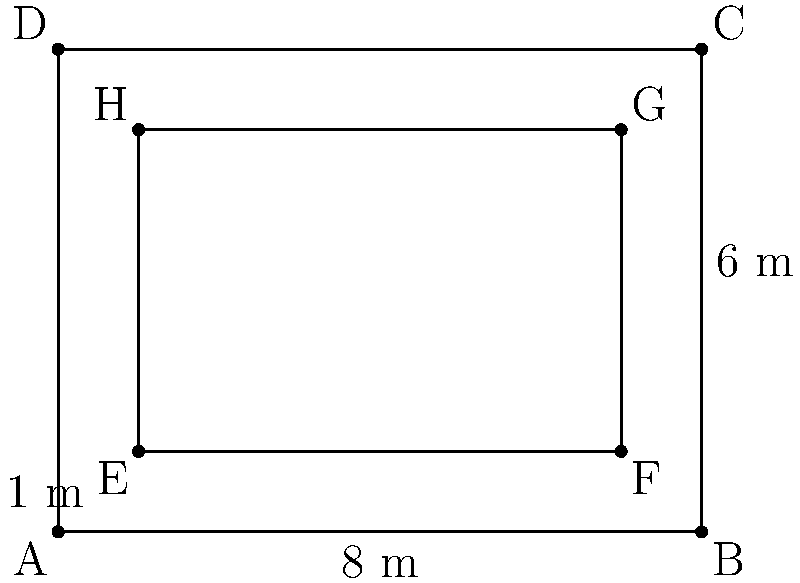Father, as we plan the landscaping for our new church courtyard, we need to calculate its perimeter. The courtyard is rectangular with dimensions 8 m by 6 m, but it has landscaped corners that are 1 m by 1 m squares. What is the perimeter of this irregularly shaped courtyard? Let's approach this step-by-step:

1) First, let's calculate the perimeter of the outer rectangle:
   $$P_{outer} = 2(8 + 6) = 28 \text{ m}$$

2) Now, we need to account for the landscaped corners. Each corner removes a 1 m by 1 m square from the perimeter.

3) For each corner, we remove 2 m from the outer perimeter (1 m from each side), but we add 1 m for the inner corner.

4) The net effect of each corner is to reduce the perimeter by 1 m.

5) There are 4 corners in total, so we need to subtract 4 m from the outer perimeter:
   $$P_{courtyard} = P_{outer} - 4 \text{ m} = 28 \text{ m} - 4 \text{ m} = 24 \text{ m}$$

Therefore, the perimeter of the irregularly shaped courtyard is 24 meters.
Answer: 24 m 